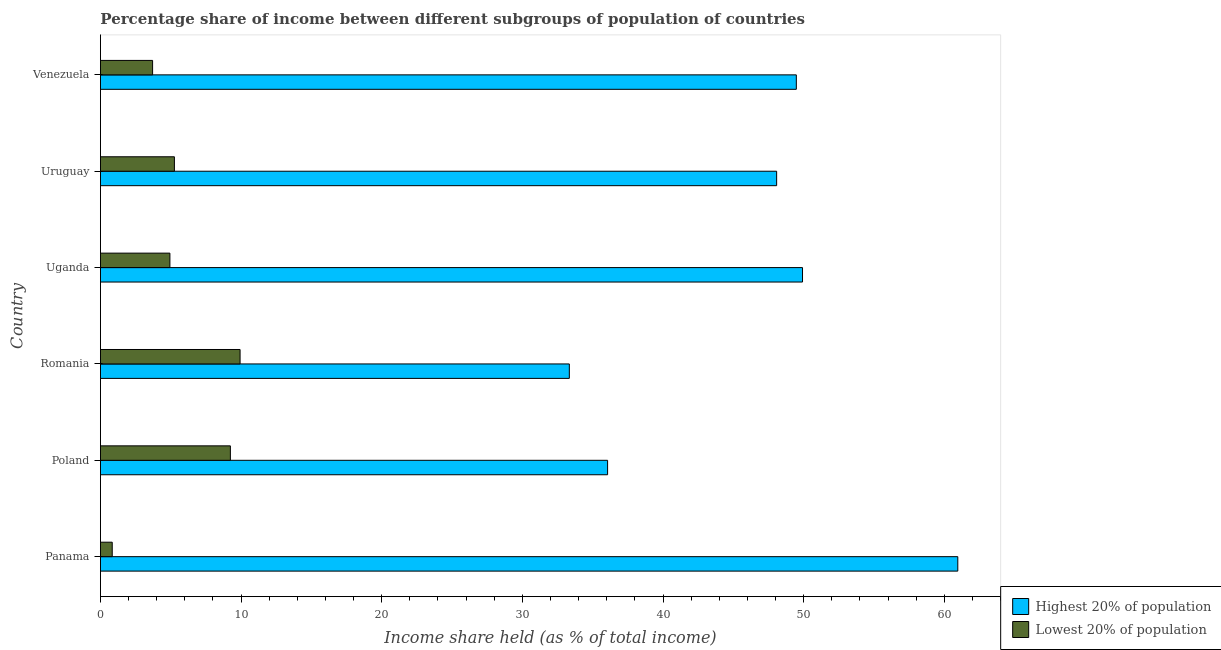How many different coloured bars are there?
Give a very brief answer. 2. What is the label of the 3rd group of bars from the top?
Ensure brevity in your answer.  Uganda. What is the income share held by highest 20% of the population in Uganda?
Offer a terse response. 49.92. Across all countries, what is the maximum income share held by highest 20% of the population?
Provide a succinct answer. 60.96. Across all countries, what is the minimum income share held by lowest 20% of the population?
Provide a short and direct response. 0.84. In which country was the income share held by lowest 20% of the population maximum?
Offer a terse response. Romania. In which country was the income share held by highest 20% of the population minimum?
Offer a terse response. Romania. What is the total income share held by lowest 20% of the population in the graph?
Your answer should be very brief. 33.92. What is the difference between the income share held by highest 20% of the population in Panama and that in Uruguay?
Provide a succinct answer. 12.88. What is the difference between the income share held by lowest 20% of the population in Panama and the income share held by highest 20% of the population in Uruguay?
Give a very brief answer. -47.24. What is the average income share held by highest 20% of the population per country?
Your response must be concise. 46.31. What is the difference between the income share held by highest 20% of the population and income share held by lowest 20% of the population in Panama?
Offer a very short reply. 60.12. In how many countries, is the income share held by lowest 20% of the population greater than 28 %?
Your answer should be compact. 0. What is the ratio of the income share held by highest 20% of the population in Romania to that in Uruguay?
Offer a very short reply. 0.69. What is the difference between the highest and the second highest income share held by lowest 20% of the population?
Your answer should be very brief. 0.69. What is the difference between the highest and the lowest income share held by highest 20% of the population?
Give a very brief answer. 27.62. What does the 2nd bar from the top in Uruguay represents?
Give a very brief answer. Highest 20% of population. What does the 1st bar from the bottom in Poland represents?
Make the answer very short. Highest 20% of population. Are all the bars in the graph horizontal?
Make the answer very short. Yes. Are the values on the major ticks of X-axis written in scientific E-notation?
Your response must be concise. No. Does the graph contain any zero values?
Give a very brief answer. No. Where does the legend appear in the graph?
Offer a terse response. Bottom right. How many legend labels are there?
Offer a terse response. 2. What is the title of the graph?
Your response must be concise. Percentage share of income between different subgroups of population of countries. Does "Domestic Liabilities" appear as one of the legend labels in the graph?
Offer a terse response. No. What is the label or title of the X-axis?
Provide a short and direct response. Income share held (as % of total income). What is the Income share held (as % of total income) of Highest 20% of population in Panama?
Ensure brevity in your answer.  60.96. What is the Income share held (as % of total income) of Lowest 20% of population in Panama?
Ensure brevity in your answer.  0.84. What is the Income share held (as % of total income) of Highest 20% of population in Poland?
Provide a short and direct response. 36.06. What is the Income share held (as % of total income) of Lowest 20% of population in Poland?
Your answer should be very brief. 9.24. What is the Income share held (as % of total income) in Highest 20% of population in Romania?
Your response must be concise. 33.34. What is the Income share held (as % of total income) of Lowest 20% of population in Romania?
Your answer should be very brief. 9.93. What is the Income share held (as % of total income) of Highest 20% of population in Uganda?
Your answer should be very brief. 49.92. What is the Income share held (as % of total income) in Lowest 20% of population in Uganda?
Provide a succinct answer. 4.94. What is the Income share held (as % of total income) in Highest 20% of population in Uruguay?
Your answer should be very brief. 48.08. What is the Income share held (as % of total income) of Lowest 20% of population in Uruguay?
Your answer should be very brief. 5.26. What is the Income share held (as % of total income) of Highest 20% of population in Venezuela?
Make the answer very short. 49.48. What is the Income share held (as % of total income) in Lowest 20% of population in Venezuela?
Ensure brevity in your answer.  3.71. Across all countries, what is the maximum Income share held (as % of total income) in Highest 20% of population?
Give a very brief answer. 60.96. Across all countries, what is the maximum Income share held (as % of total income) in Lowest 20% of population?
Provide a short and direct response. 9.93. Across all countries, what is the minimum Income share held (as % of total income) of Highest 20% of population?
Offer a terse response. 33.34. Across all countries, what is the minimum Income share held (as % of total income) in Lowest 20% of population?
Give a very brief answer. 0.84. What is the total Income share held (as % of total income) of Highest 20% of population in the graph?
Offer a terse response. 277.84. What is the total Income share held (as % of total income) of Lowest 20% of population in the graph?
Offer a very short reply. 33.92. What is the difference between the Income share held (as % of total income) of Highest 20% of population in Panama and that in Poland?
Offer a very short reply. 24.9. What is the difference between the Income share held (as % of total income) of Lowest 20% of population in Panama and that in Poland?
Provide a succinct answer. -8.4. What is the difference between the Income share held (as % of total income) of Highest 20% of population in Panama and that in Romania?
Ensure brevity in your answer.  27.62. What is the difference between the Income share held (as % of total income) in Lowest 20% of population in Panama and that in Romania?
Give a very brief answer. -9.09. What is the difference between the Income share held (as % of total income) in Highest 20% of population in Panama and that in Uganda?
Your response must be concise. 11.04. What is the difference between the Income share held (as % of total income) of Lowest 20% of population in Panama and that in Uganda?
Provide a short and direct response. -4.1. What is the difference between the Income share held (as % of total income) of Highest 20% of population in Panama and that in Uruguay?
Provide a short and direct response. 12.88. What is the difference between the Income share held (as % of total income) in Lowest 20% of population in Panama and that in Uruguay?
Your answer should be very brief. -4.42. What is the difference between the Income share held (as % of total income) in Highest 20% of population in Panama and that in Venezuela?
Make the answer very short. 11.48. What is the difference between the Income share held (as % of total income) in Lowest 20% of population in Panama and that in Venezuela?
Your answer should be compact. -2.87. What is the difference between the Income share held (as % of total income) of Highest 20% of population in Poland and that in Romania?
Keep it short and to the point. 2.72. What is the difference between the Income share held (as % of total income) of Lowest 20% of population in Poland and that in Romania?
Provide a short and direct response. -0.69. What is the difference between the Income share held (as % of total income) of Highest 20% of population in Poland and that in Uganda?
Your answer should be compact. -13.86. What is the difference between the Income share held (as % of total income) of Highest 20% of population in Poland and that in Uruguay?
Provide a succinct answer. -12.02. What is the difference between the Income share held (as % of total income) of Lowest 20% of population in Poland and that in Uruguay?
Keep it short and to the point. 3.98. What is the difference between the Income share held (as % of total income) in Highest 20% of population in Poland and that in Venezuela?
Provide a succinct answer. -13.42. What is the difference between the Income share held (as % of total income) in Lowest 20% of population in Poland and that in Venezuela?
Keep it short and to the point. 5.53. What is the difference between the Income share held (as % of total income) in Highest 20% of population in Romania and that in Uganda?
Keep it short and to the point. -16.58. What is the difference between the Income share held (as % of total income) of Lowest 20% of population in Romania and that in Uganda?
Offer a terse response. 4.99. What is the difference between the Income share held (as % of total income) of Highest 20% of population in Romania and that in Uruguay?
Offer a very short reply. -14.74. What is the difference between the Income share held (as % of total income) in Lowest 20% of population in Romania and that in Uruguay?
Ensure brevity in your answer.  4.67. What is the difference between the Income share held (as % of total income) in Highest 20% of population in Romania and that in Venezuela?
Give a very brief answer. -16.14. What is the difference between the Income share held (as % of total income) of Lowest 20% of population in Romania and that in Venezuela?
Provide a succinct answer. 6.22. What is the difference between the Income share held (as % of total income) of Highest 20% of population in Uganda and that in Uruguay?
Your answer should be very brief. 1.84. What is the difference between the Income share held (as % of total income) of Lowest 20% of population in Uganda and that in Uruguay?
Keep it short and to the point. -0.32. What is the difference between the Income share held (as % of total income) of Highest 20% of population in Uganda and that in Venezuela?
Your answer should be compact. 0.44. What is the difference between the Income share held (as % of total income) of Lowest 20% of population in Uganda and that in Venezuela?
Give a very brief answer. 1.23. What is the difference between the Income share held (as % of total income) in Highest 20% of population in Uruguay and that in Venezuela?
Provide a short and direct response. -1.4. What is the difference between the Income share held (as % of total income) in Lowest 20% of population in Uruguay and that in Venezuela?
Offer a very short reply. 1.55. What is the difference between the Income share held (as % of total income) in Highest 20% of population in Panama and the Income share held (as % of total income) in Lowest 20% of population in Poland?
Keep it short and to the point. 51.72. What is the difference between the Income share held (as % of total income) in Highest 20% of population in Panama and the Income share held (as % of total income) in Lowest 20% of population in Romania?
Your answer should be compact. 51.03. What is the difference between the Income share held (as % of total income) in Highest 20% of population in Panama and the Income share held (as % of total income) in Lowest 20% of population in Uganda?
Offer a very short reply. 56.02. What is the difference between the Income share held (as % of total income) of Highest 20% of population in Panama and the Income share held (as % of total income) of Lowest 20% of population in Uruguay?
Your response must be concise. 55.7. What is the difference between the Income share held (as % of total income) in Highest 20% of population in Panama and the Income share held (as % of total income) in Lowest 20% of population in Venezuela?
Ensure brevity in your answer.  57.25. What is the difference between the Income share held (as % of total income) in Highest 20% of population in Poland and the Income share held (as % of total income) in Lowest 20% of population in Romania?
Offer a very short reply. 26.13. What is the difference between the Income share held (as % of total income) of Highest 20% of population in Poland and the Income share held (as % of total income) of Lowest 20% of population in Uganda?
Offer a very short reply. 31.12. What is the difference between the Income share held (as % of total income) of Highest 20% of population in Poland and the Income share held (as % of total income) of Lowest 20% of population in Uruguay?
Keep it short and to the point. 30.8. What is the difference between the Income share held (as % of total income) of Highest 20% of population in Poland and the Income share held (as % of total income) of Lowest 20% of population in Venezuela?
Your response must be concise. 32.35. What is the difference between the Income share held (as % of total income) of Highest 20% of population in Romania and the Income share held (as % of total income) of Lowest 20% of population in Uganda?
Your answer should be compact. 28.4. What is the difference between the Income share held (as % of total income) in Highest 20% of population in Romania and the Income share held (as % of total income) in Lowest 20% of population in Uruguay?
Your answer should be compact. 28.08. What is the difference between the Income share held (as % of total income) of Highest 20% of population in Romania and the Income share held (as % of total income) of Lowest 20% of population in Venezuela?
Keep it short and to the point. 29.63. What is the difference between the Income share held (as % of total income) of Highest 20% of population in Uganda and the Income share held (as % of total income) of Lowest 20% of population in Uruguay?
Ensure brevity in your answer.  44.66. What is the difference between the Income share held (as % of total income) of Highest 20% of population in Uganda and the Income share held (as % of total income) of Lowest 20% of population in Venezuela?
Offer a very short reply. 46.21. What is the difference between the Income share held (as % of total income) in Highest 20% of population in Uruguay and the Income share held (as % of total income) in Lowest 20% of population in Venezuela?
Offer a terse response. 44.37. What is the average Income share held (as % of total income) of Highest 20% of population per country?
Provide a succinct answer. 46.31. What is the average Income share held (as % of total income) in Lowest 20% of population per country?
Offer a very short reply. 5.65. What is the difference between the Income share held (as % of total income) in Highest 20% of population and Income share held (as % of total income) in Lowest 20% of population in Panama?
Your answer should be compact. 60.12. What is the difference between the Income share held (as % of total income) in Highest 20% of population and Income share held (as % of total income) in Lowest 20% of population in Poland?
Give a very brief answer. 26.82. What is the difference between the Income share held (as % of total income) in Highest 20% of population and Income share held (as % of total income) in Lowest 20% of population in Romania?
Offer a very short reply. 23.41. What is the difference between the Income share held (as % of total income) in Highest 20% of population and Income share held (as % of total income) in Lowest 20% of population in Uganda?
Offer a terse response. 44.98. What is the difference between the Income share held (as % of total income) of Highest 20% of population and Income share held (as % of total income) of Lowest 20% of population in Uruguay?
Your response must be concise. 42.82. What is the difference between the Income share held (as % of total income) of Highest 20% of population and Income share held (as % of total income) of Lowest 20% of population in Venezuela?
Your answer should be compact. 45.77. What is the ratio of the Income share held (as % of total income) of Highest 20% of population in Panama to that in Poland?
Offer a terse response. 1.69. What is the ratio of the Income share held (as % of total income) in Lowest 20% of population in Panama to that in Poland?
Your answer should be compact. 0.09. What is the ratio of the Income share held (as % of total income) of Highest 20% of population in Panama to that in Romania?
Offer a terse response. 1.83. What is the ratio of the Income share held (as % of total income) in Lowest 20% of population in Panama to that in Romania?
Give a very brief answer. 0.08. What is the ratio of the Income share held (as % of total income) in Highest 20% of population in Panama to that in Uganda?
Your answer should be compact. 1.22. What is the ratio of the Income share held (as % of total income) in Lowest 20% of population in Panama to that in Uganda?
Give a very brief answer. 0.17. What is the ratio of the Income share held (as % of total income) in Highest 20% of population in Panama to that in Uruguay?
Ensure brevity in your answer.  1.27. What is the ratio of the Income share held (as % of total income) of Lowest 20% of population in Panama to that in Uruguay?
Offer a terse response. 0.16. What is the ratio of the Income share held (as % of total income) in Highest 20% of population in Panama to that in Venezuela?
Your answer should be very brief. 1.23. What is the ratio of the Income share held (as % of total income) of Lowest 20% of population in Panama to that in Venezuela?
Offer a very short reply. 0.23. What is the ratio of the Income share held (as % of total income) of Highest 20% of population in Poland to that in Romania?
Offer a terse response. 1.08. What is the ratio of the Income share held (as % of total income) in Lowest 20% of population in Poland to that in Romania?
Your response must be concise. 0.93. What is the ratio of the Income share held (as % of total income) in Highest 20% of population in Poland to that in Uganda?
Make the answer very short. 0.72. What is the ratio of the Income share held (as % of total income) in Lowest 20% of population in Poland to that in Uganda?
Your answer should be very brief. 1.87. What is the ratio of the Income share held (as % of total income) of Highest 20% of population in Poland to that in Uruguay?
Your answer should be compact. 0.75. What is the ratio of the Income share held (as % of total income) in Lowest 20% of population in Poland to that in Uruguay?
Offer a terse response. 1.76. What is the ratio of the Income share held (as % of total income) of Highest 20% of population in Poland to that in Venezuela?
Offer a terse response. 0.73. What is the ratio of the Income share held (as % of total income) of Lowest 20% of population in Poland to that in Venezuela?
Your response must be concise. 2.49. What is the ratio of the Income share held (as % of total income) of Highest 20% of population in Romania to that in Uganda?
Provide a succinct answer. 0.67. What is the ratio of the Income share held (as % of total income) of Lowest 20% of population in Romania to that in Uganda?
Make the answer very short. 2.01. What is the ratio of the Income share held (as % of total income) of Highest 20% of population in Romania to that in Uruguay?
Your answer should be compact. 0.69. What is the ratio of the Income share held (as % of total income) in Lowest 20% of population in Romania to that in Uruguay?
Offer a terse response. 1.89. What is the ratio of the Income share held (as % of total income) in Highest 20% of population in Romania to that in Venezuela?
Offer a terse response. 0.67. What is the ratio of the Income share held (as % of total income) of Lowest 20% of population in Romania to that in Venezuela?
Your answer should be compact. 2.68. What is the ratio of the Income share held (as % of total income) in Highest 20% of population in Uganda to that in Uruguay?
Your answer should be very brief. 1.04. What is the ratio of the Income share held (as % of total income) in Lowest 20% of population in Uganda to that in Uruguay?
Make the answer very short. 0.94. What is the ratio of the Income share held (as % of total income) of Highest 20% of population in Uganda to that in Venezuela?
Ensure brevity in your answer.  1.01. What is the ratio of the Income share held (as % of total income) of Lowest 20% of population in Uganda to that in Venezuela?
Give a very brief answer. 1.33. What is the ratio of the Income share held (as % of total income) in Highest 20% of population in Uruguay to that in Venezuela?
Your answer should be compact. 0.97. What is the ratio of the Income share held (as % of total income) of Lowest 20% of population in Uruguay to that in Venezuela?
Your response must be concise. 1.42. What is the difference between the highest and the second highest Income share held (as % of total income) of Highest 20% of population?
Provide a succinct answer. 11.04. What is the difference between the highest and the second highest Income share held (as % of total income) of Lowest 20% of population?
Ensure brevity in your answer.  0.69. What is the difference between the highest and the lowest Income share held (as % of total income) in Highest 20% of population?
Make the answer very short. 27.62. What is the difference between the highest and the lowest Income share held (as % of total income) in Lowest 20% of population?
Provide a succinct answer. 9.09. 